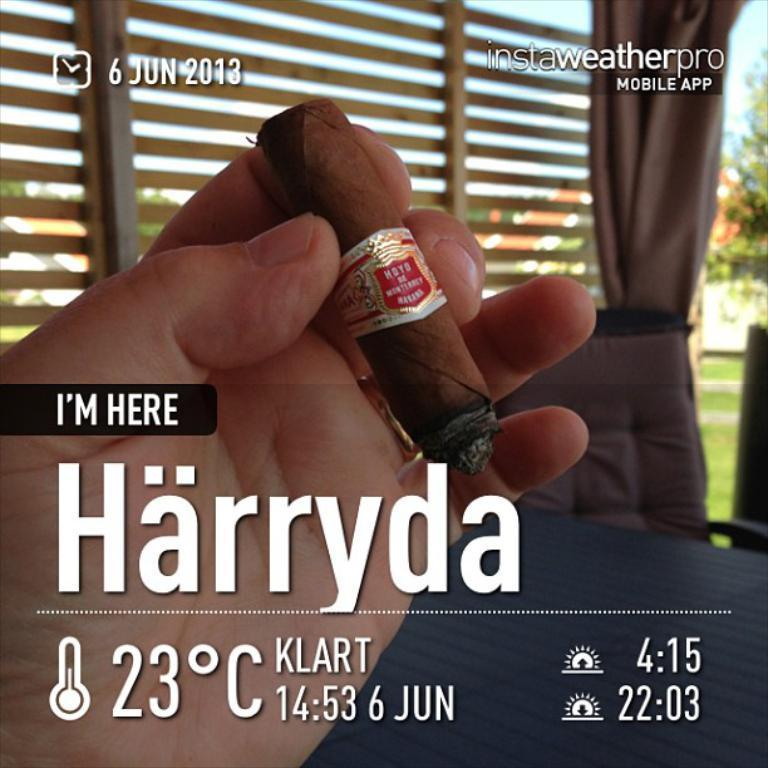Could you give a brief overview of what you see in this image? Here we can see a hand of a person holding a cigarette. In the background we can see a chair, curtain, grass, wall, trees, and sky. 